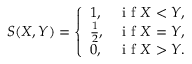<formula> <loc_0><loc_0><loc_500><loc_500>S ( X , Y ) = \left \{ \begin{array} { l l } { 1 , } & { i f X < Y , } \\ { \frac { 1 } { 2 } , } & { i f X = Y , } \\ { 0 , } & { i f X > Y . } \end{array}</formula> 